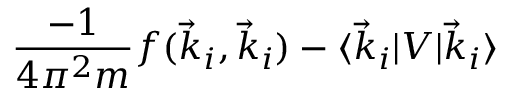<formula> <loc_0><loc_0><loc_500><loc_500>\frac { - 1 } { 4 \pi ^ { 2 } m } f ( \vec { k } _ { i } , \vec { k } _ { i } ) - \langle \vec { k } _ { i } | V | \vec { k } _ { i } \rangle</formula> 